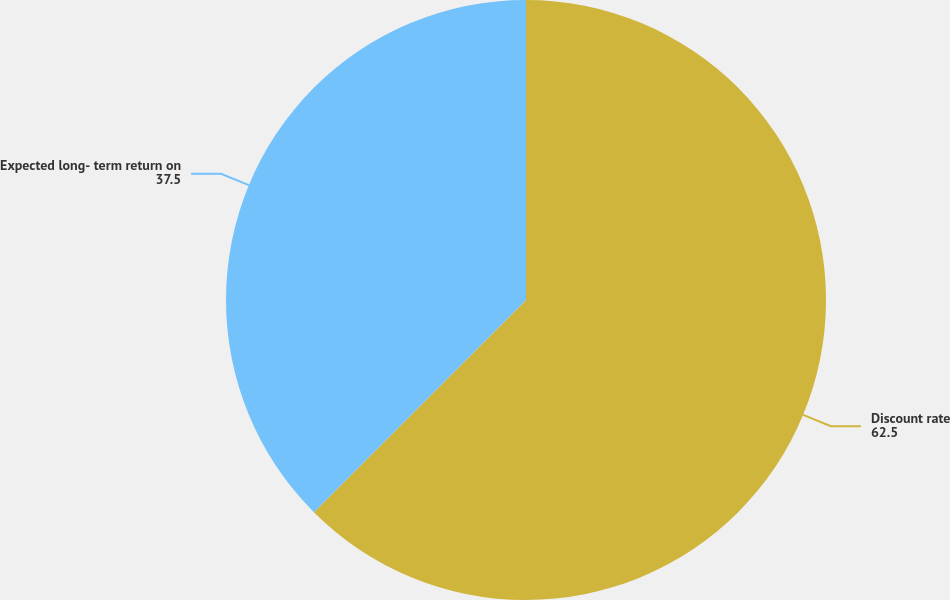Convert chart to OTSL. <chart><loc_0><loc_0><loc_500><loc_500><pie_chart><fcel>Discount rate<fcel>Expected long- term return on<nl><fcel>62.5%<fcel>37.5%<nl></chart> 